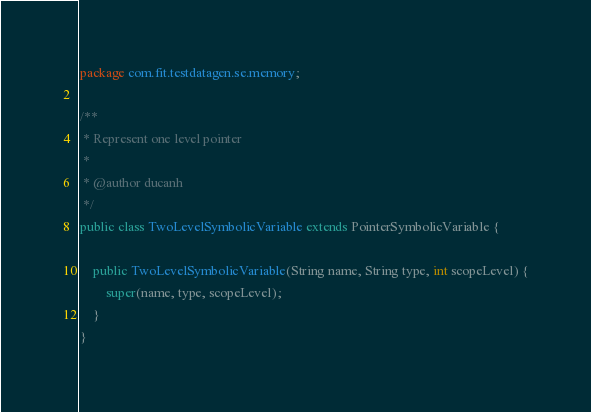<code> <loc_0><loc_0><loc_500><loc_500><_Java_>package com.fit.testdatagen.se.memory;

/**
 * Represent one level pointer
 *
 * @author ducanh
 */
public class TwoLevelSymbolicVariable extends PointerSymbolicVariable {

    public TwoLevelSymbolicVariable(String name, String type, int scopeLevel) {
        super(name, type, scopeLevel);
    }
}
</code> 